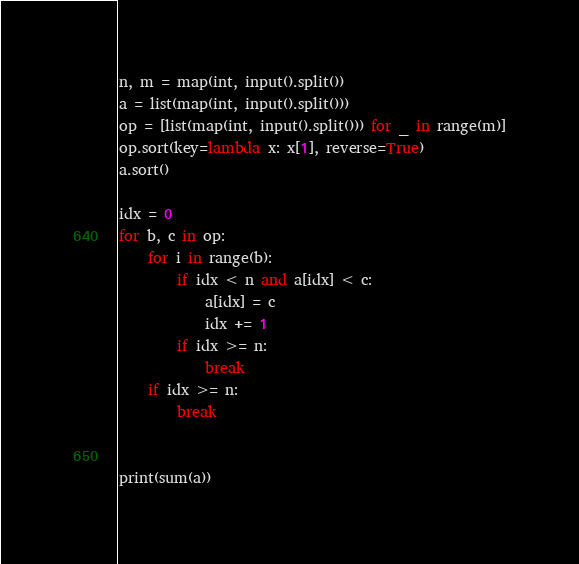<code> <loc_0><loc_0><loc_500><loc_500><_Python_>n, m = map(int, input().split())
a = list(map(int, input().split()))
op = [list(map(int, input().split())) for _ in range(m)]
op.sort(key=lambda x: x[1], reverse=True)
a.sort()

idx = 0
for b, c in op:
    for i in range(b):
        if idx < n and a[idx] < c:
            a[idx] = c
            idx += 1
        if idx >= n:
            break
    if idx >= n:
        break


print(sum(a))
</code> 